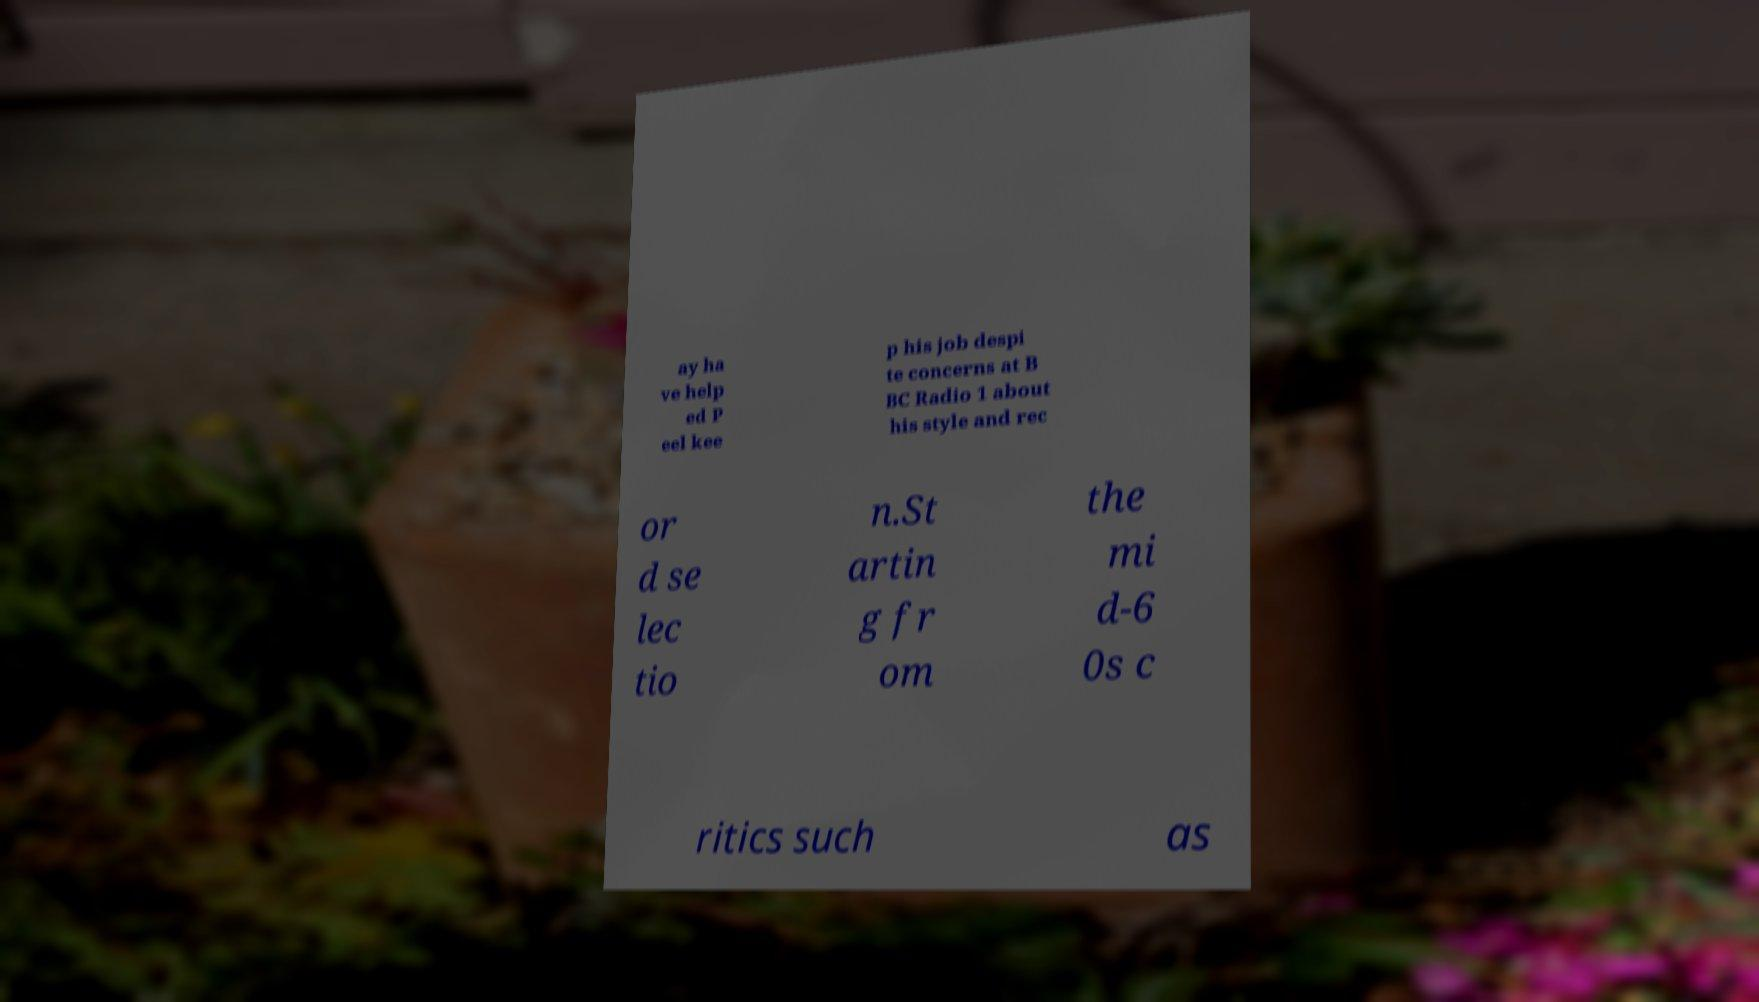I need the written content from this picture converted into text. Can you do that? ay ha ve help ed P eel kee p his job despi te concerns at B BC Radio 1 about his style and rec or d se lec tio n.St artin g fr om the mi d-6 0s c ritics such as 